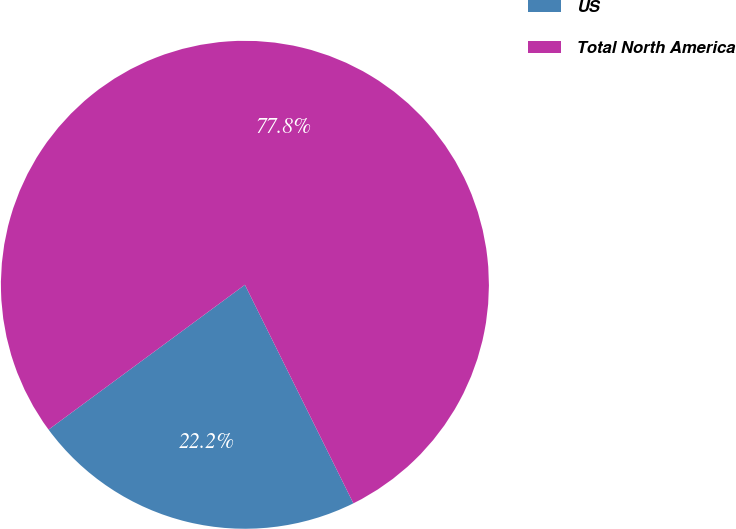Convert chart to OTSL. <chart><loc_0><loc_0><loc_500><loc_500><pie_chart><fcel>US<fcel>Total North America<nl><fcel>22.22%<fcel>77.78%<nl></chart> 